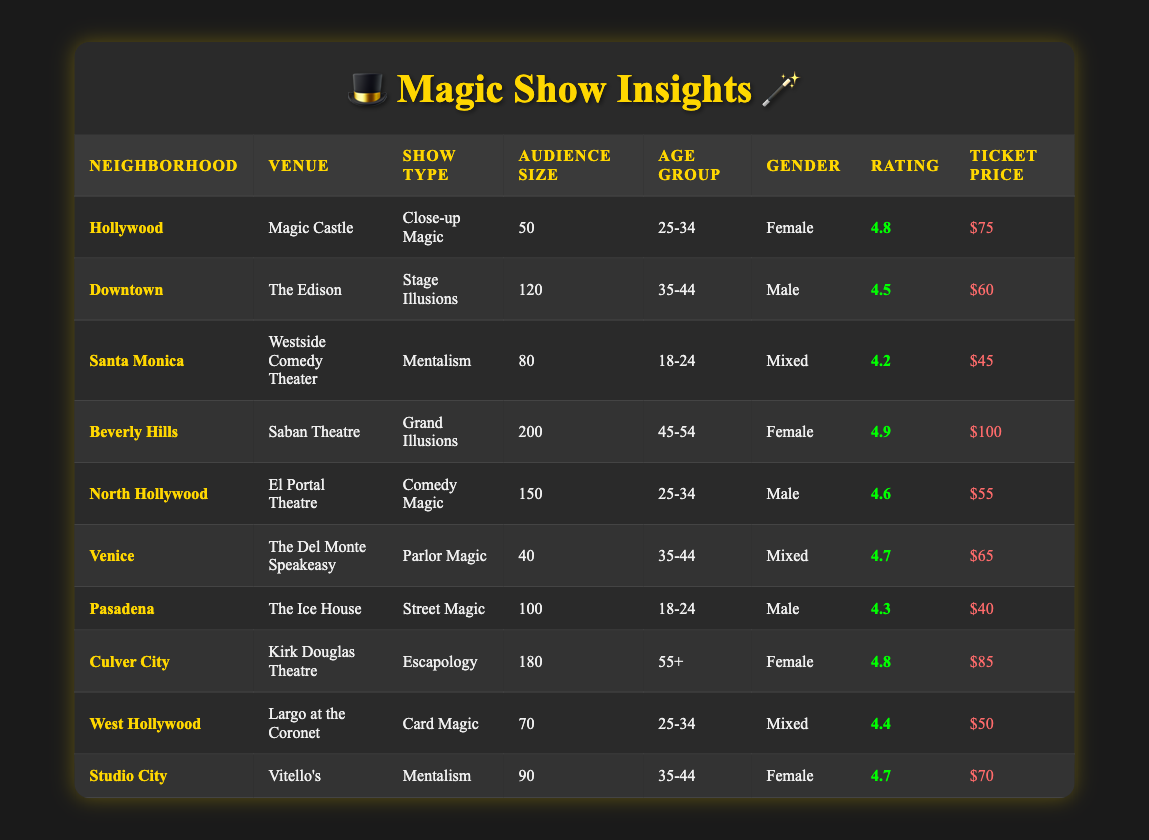What is the highest rating achieved for a magic show? The highest rating in the table can be found by examining the "Rating" column. The values are: 4.8, 4.5, 4.2, 4.9, 4.6, 4.7, 4.3, 4.8, 4.4, and 4.7. The highest among these is 4.9.
Answer: 4.9 Which neighborhood had the largest audience size? By looking at the "Audience Size" column, the values are: 50, 120, 80, 200, 150, 40, 100, 180, 70, and 90. The largest value is 200, which corresponds to the "Beverly Hills" neighborhood.
Answer: Beverly Hills What is the average ticket price across all shows? First, sum the "Ticket Price" column values: 75 + 60 + 45 + 100 + 55 + 65 + 40 + 85 + 50 + 70 = 700. There are 10 shows, so the average is 700 / 10 = 70.
Answer: 70 Did any show have an audience composed entirely of females? By checking the "Gender" column, the values are "Female," "Male," "Mixed," and "Female." No shows were labelled solely as "Female," so the answer is no.
Answer: No What is the neighborhood with the highest average rating for shows in the '25-34' age group? First, identify rows with age "25-34": Hollywood (4.8), North Hollywood (4.6), and West Hollywood (4.4). Average these: (4.8 + 4.6 + 4.4) / 3 = 4.53333. Thus, the best rating is from "Hollywood."
Answer: Hollywood 